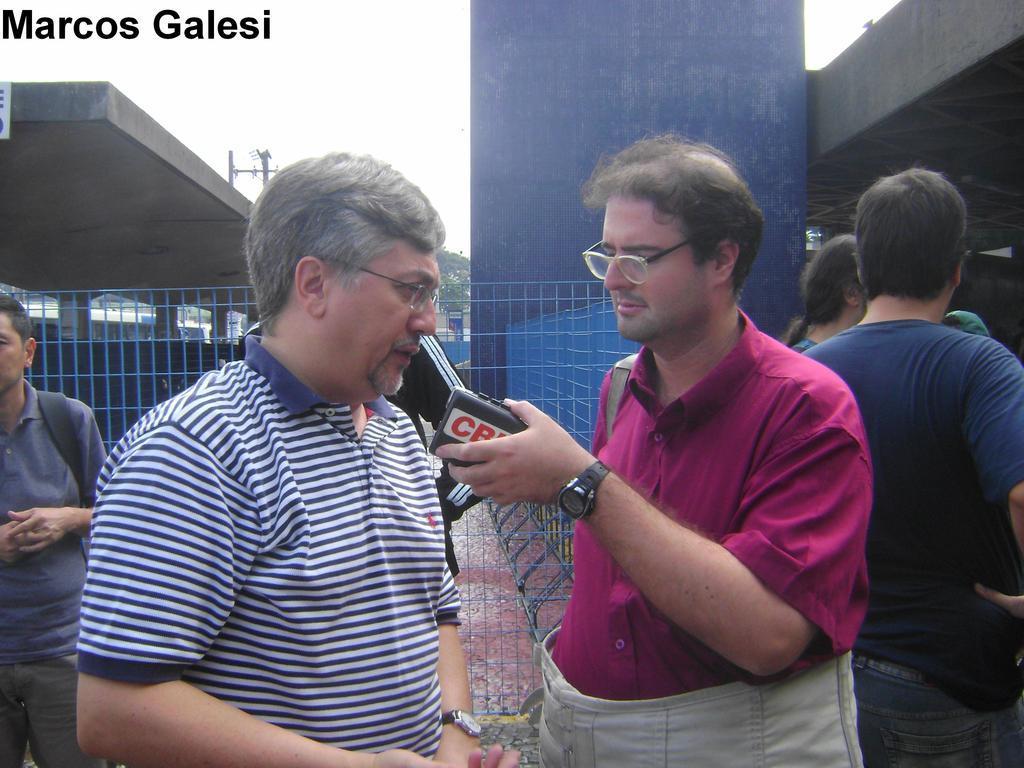How would you summarize this image in a sentence or two? In the center of the image we can see two men are standing and a man is holding an object. In the background of the image we can see the buildings, roof, mesh, pillar, poles, tree, floor and some people are standing. At the top of the image we can see the sky and text. 